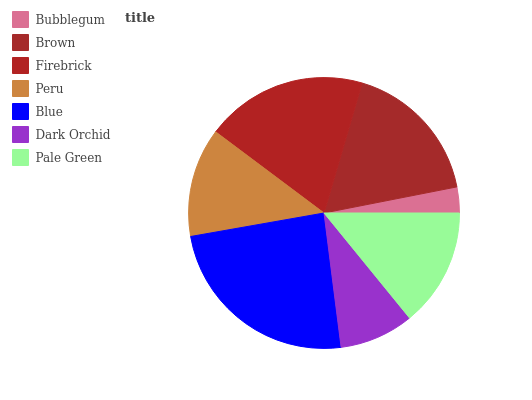Is Bubblegum the minimum?
Answer yes or no. Yes. Is Blue the maximum?
Answer yes or no. Yes. Is Brown the minimum?
Answer yes or no. No. Is Brown the maximum?
Answer yes or no. No. Is Brown greater than Bubblegum?
Answer yes or no. Yes. Is Bubblegum less than Brown?
Answer yes or no. Yes. Is Bubblegum greater than Brown?
Answer yes or no. No. Is Brown less than Bubblegum?
Answer yes or no. No. Is Pale Green the high median?
Answer yes or no. Yes. Is Pale Green the low median?
Answer yes or no. Yes. Is Peru the high median?
Answer yes or no. No. Is Firebrick the low median?
Answer yes or no. No. 